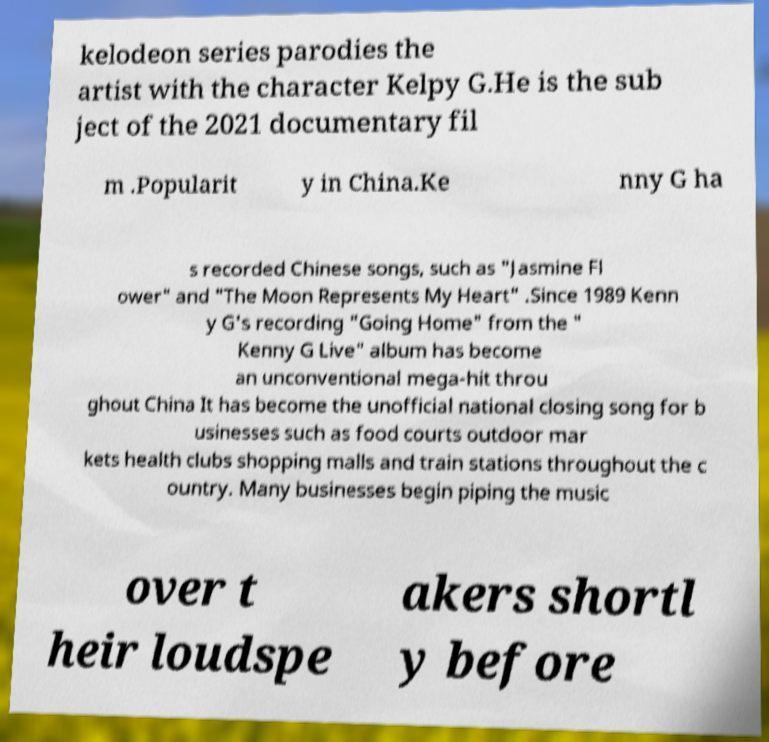Can you accurately transcribe the text from the provided image for me? kelodeon series parodies the artist with the character Kelpy G.He is the sub ject of the 2021 documentary fil m .Popularit y in China.Ke nny G ha s recorded Chinese songs, such as "Jasmine Fl ower" and "The Moon Represents My Heart" .Since 1989 Kenn y G's recording "Going Home" from the " Kenny G Live" album has become an unconventional mega-hit throu ghout China It has become the unofficial national closing song for b usinesses such as food courts outdoor mar kets health clubs shopping malls and train stations throughout the c ountry. Many businesses begin piping the music over t heir loudspe akers shortl y before 